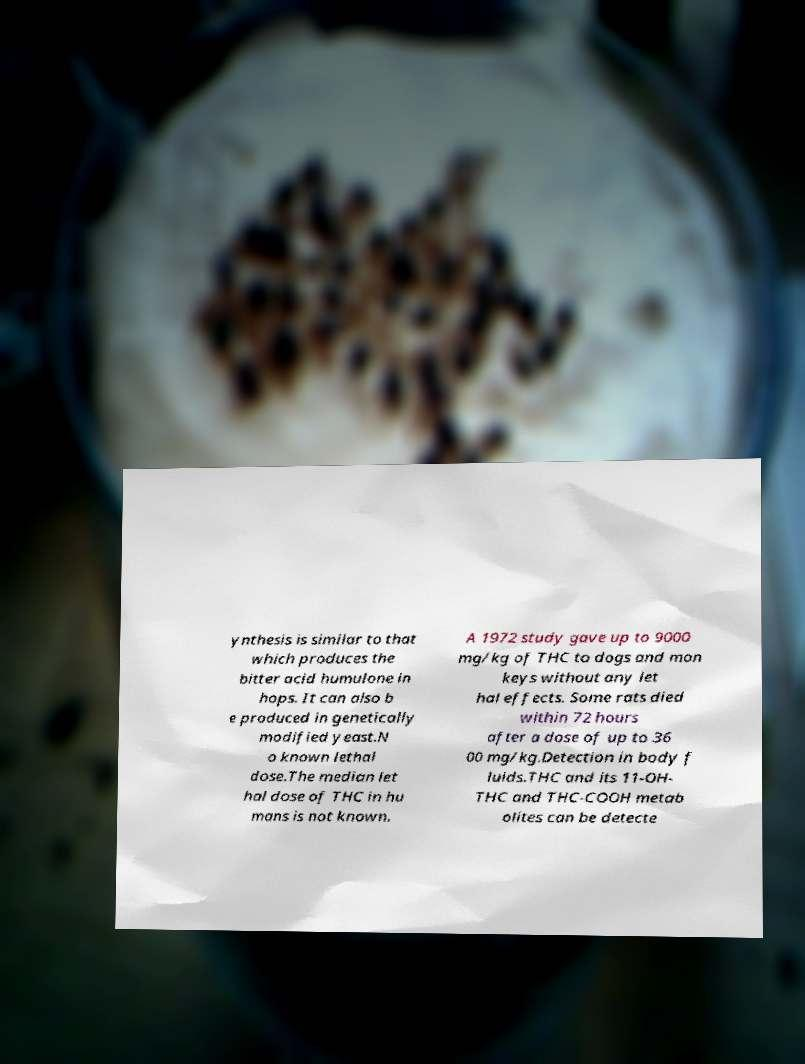What messages or text are displayed in this image? I need them in a readable, typed format. ynthesis is similar to that which produces the bitter acid humulone in hops. It can also b e produced in genetically modified yeast.N o known lethal dose.The median let hal dose of THC in hu mans is not known. A 1972 study gave up to 9000 mg/kg of THC to dogs and mon keys without any let hal effects. Some rats died within 72 hours after a dose of up to 36 00 mg/kg.Detection in body f luids.THC and its 11-OH- THC and THC-COOH metab olites can be detecte 